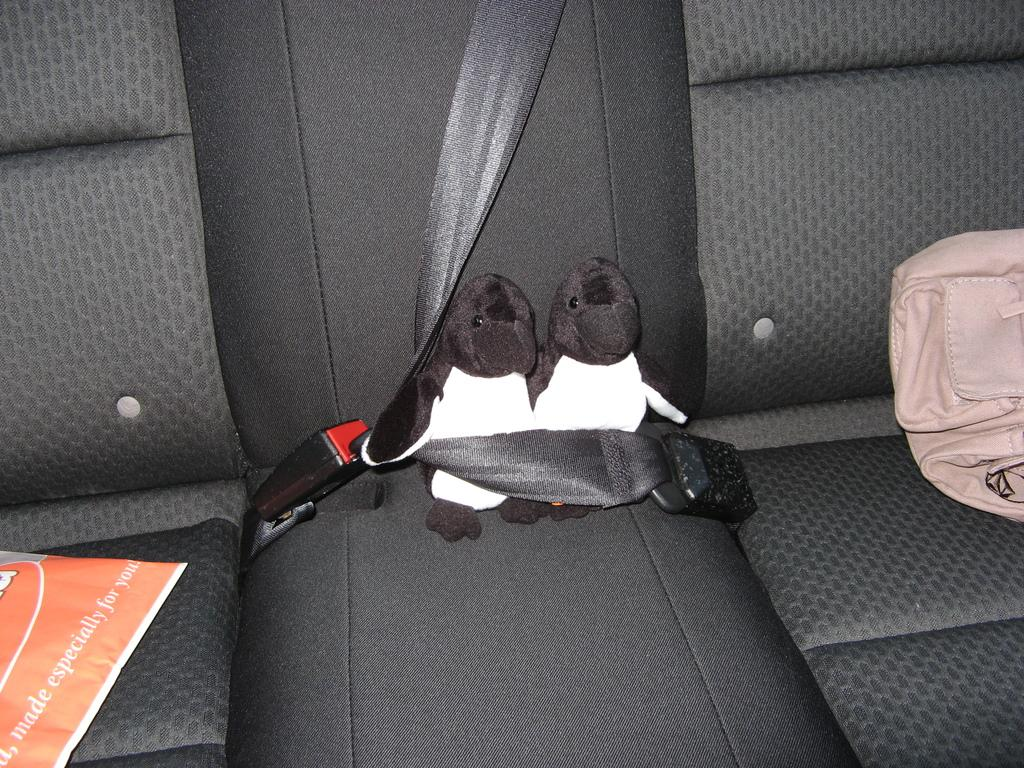What part of a vehicle is shown in the image? The image shows a vehicle's back seat. What items can be seen on the back seat? There are soft toys and bags on the seat. How many bags are visible on the seat? There is one bag and one paper bag on the seat. Can you hear the sound of the waves in the image? There are no waves or sounds present in the image, as it shows a vehicle's back seat with soft toys and bags. 